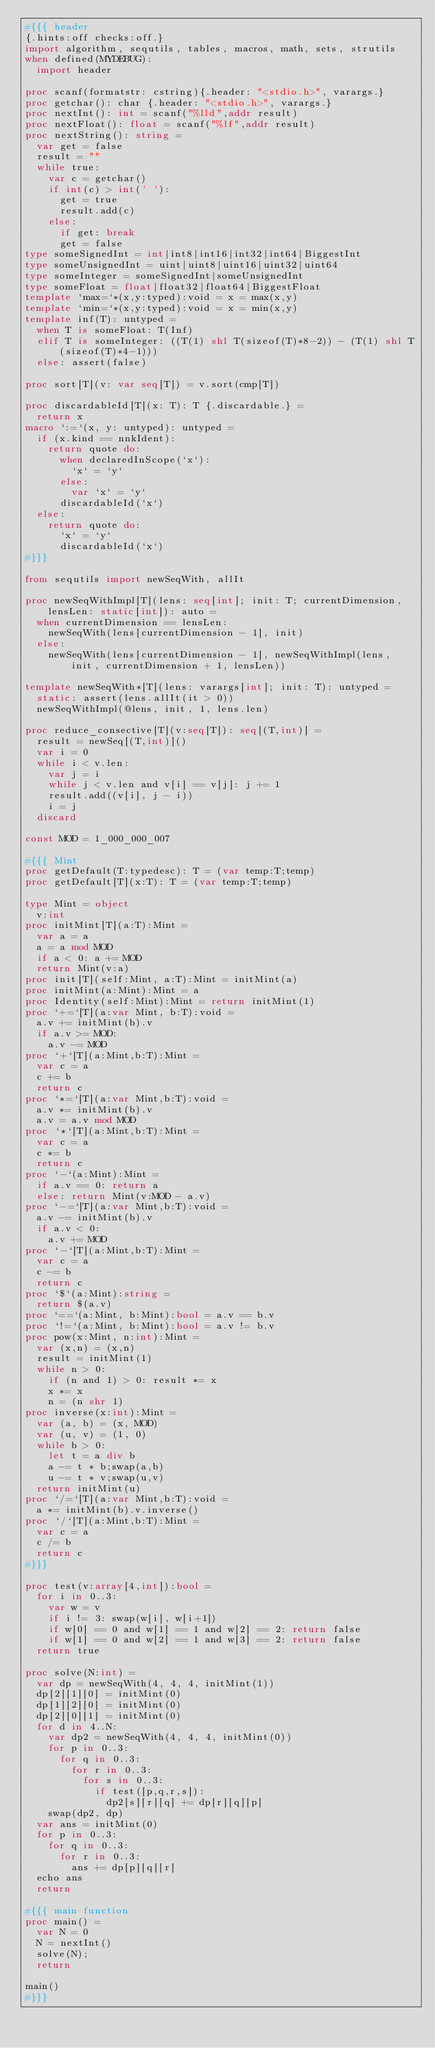<code> <loc_0><loc_0><loc_500><loc_500><_Nim_>#{{{ header
{.hints:off checks:off.}
import algorithm, sequtils, tables, macros, math, sets, strutils
when defined(MYDEBUG):
  import header

proc scanf(formatstr: cstring){.header: "<stdio.h>", varargs.}
proc getchar(): char {.header: "<stdio.h>", varargs.}
proc nextInt(): int = scanf("%lld",addr result)
proc nextFloat(): float = scanf("%lf",addr result)
proc nextString(): string =
  var get = false
  result = ""
  while true:
    var c = getchar()
    if int(c) > int(' '):
      get = true
      result.add(c)
    else:
      if get: break
      get = false
type someSignedInt = int|int8|int16|int32|int64|BiggestInt
type someUnsignedInt = uint|uint8|uint16|uint32|uint64
type someInteger = someSignedInt|someUnsignedInt
type someFloat = float|float32|float64|BiggestFloat
template `max=`*(x,y:typed):void = x = max(x,y)
template `min=`*(x,y:typed):void = x = min(x,y)
template inf(T): untyped = 
  when T is someFloat: T(Inf)
  elif T is someInteger: ((T(1) shl T(sizeof(T)*8-2)) - (T(1) shl T(sizeof(T)*4-1)))
  else: assert(false)

proc sort[T](v: var seq[T]) = v.sort(cmp[T])

proc discardableId[T](x: T): T {.discardable.} =
  return x
macro `:=`(x, y: untyped): untyped =
  if (x.kind == nnkIdent):
    return quote do:
      when declaredInScope(`x`):
        `x` = `y`
      else:
        var `x` = `y`
      discardableId(`x`)
  else:
    return quote do:
      `x` = `y`
      discardableId(`x`)
#}}}

from sequtils import newSeqWith, allIt

proc newSeqWithImpl[T](lens: seq[int]; init: T; currentDimension, lensLen: static[int]): auto =
  when currentDimension == lensLen:
    newSeqWith(lens[currentDimension - 1], init)
  else:
    newSeqWith(lens[currentDimension - 1], newSeqWithImpl(lens, init, currentDimension + 1, lensLen))

template newSeqWith*[T](lens: varargs[int]; init: T): untyped =
  static: assert(lens.allIt(it > 0))
  newSeqWithImpl(@lens, init, 1, lens.len)

proc reduce_consective[T](v:seq[T]): seq[(T,int)] =
  result = newSeq[(T,int)]()
  var i = 0
  while i < v.len:
    var j = i
    while j < v.len and v[i] == v[j]: j += 1
    result.add((v[i], j - i))
    i = j
  discard

const MOD = 1_000_000_007

#{{{ Mint
proc getDefault(T:typedesc): T = (var temp:T;temp)
proc getDefault[T](x:T): T = (var temp:T;temp)

type Mint = object
  v:int
proc initMint[T](a:T):Mint =
  var a = a
  a = a mod MOD
  if a < 0: a += MOD
  return Mint(v:a)
proc init[T](self:Mint, a:T):Mint = initMint(a)
proc initMint(a:Mint):Mint = a
proc Identity(self:Mint):Mint = return initMint(1)
proc `+=`[T](a:var Mint, b:T):void =
  a.v += initMint(b).v
  if a.v >= MOD:
    a.v -= MOD
proc `+`[T](a:Mint,b:T):Mint =
  var c = a
  c += b
  return c
proc `*=`[T](a:var Mint,b:T):void =
  a.v *= initMint(b).v
  a.v = a.v mod MOD
proc `*`[T](a:Mint,b:T):Mint =
  var c = a
  c *= b
  return c
proc `-`(a:Mint):Mint =
  if a.v == 0: return a
  else: return Mint(v:MOD - a.v)
proc `-=`[T](a:var Mint,b:T):void =
  a.v -= initMint(b).v
  if a.v < 0:
    a.v += MOD
proc `-`[T](a:Mint,b:T):Mint =
  var c = a
  c -= b
  return c
proc `$`(a:Mint):string =
  return $(a.v)
proc `==`(a:Mint, b:Mint):bool = a.v == b.v
proc `!=`(a:Mint, b:Mint):bool = a.v != b.v
proc pow(x:Mint, n:int):Mint =
  var (x,n) = (x,n)
  result = initMint(1)
  while n > 0:
    if (n and 1) > 0: result *= x
    x *= x
    n = (n shr 1)
proc inverse(x:int):Mint =
  var (a, b) = (x, MOD)
  var (u, v) = (1, 0)
  while b > 0:
    let t = a div b
    a -= t * b;swap(a,b)
    u -= t * v;swap(u,v)
  return initMint(u)
proc `/=`[T](a:var Mint,b:T):void =
  a *= initMint(b).v.inverse()
proc `/`[T](a:Mint,b:T):Mint =
  var c = a
  c /= b
  return c
#}}}

proc test(v:array[4,int]):bool =
  for i in 0..3:
    var w = v
    if i != 3: swap(w[i], w[i+1])
    if w[0] == 0 and w[1] == 1 and w[2] == 2: return false
    if w[1] == 0 and w[2] == 1 and w[3] == 2: return false
  return true

proc solve(N:int) =
  var dp = newSeqWith(4, 4, 4, initMint(1))
  dp[2][1][0] = initMint(0)
  dp[1][2][0] = initMint(0)
  dp[2][0][1] = initMint(0)
  for d in 4..N:
    var dp2 = newSeqWith(4, 4, 4, initMint(0))
    for p in 0..3:
      for q in 0..3:
        for r in 0..3:
          for s in 0..3:
            if test([p,q,r,s]):
              dp2[s][r][q] += dp[r][q][p]
    swap(dp2, dp)
  var ans = initMint(0)
  for p in 0..3:
    for q in 0..3:
      for r in 0..3:
        ans += dp[p][q][r]
  echo ans
  return

#{{{ main function
proc main() =
  var N = 0
  N = nextInt()
  solve(N);
  return

main()
#}}}
</code> 